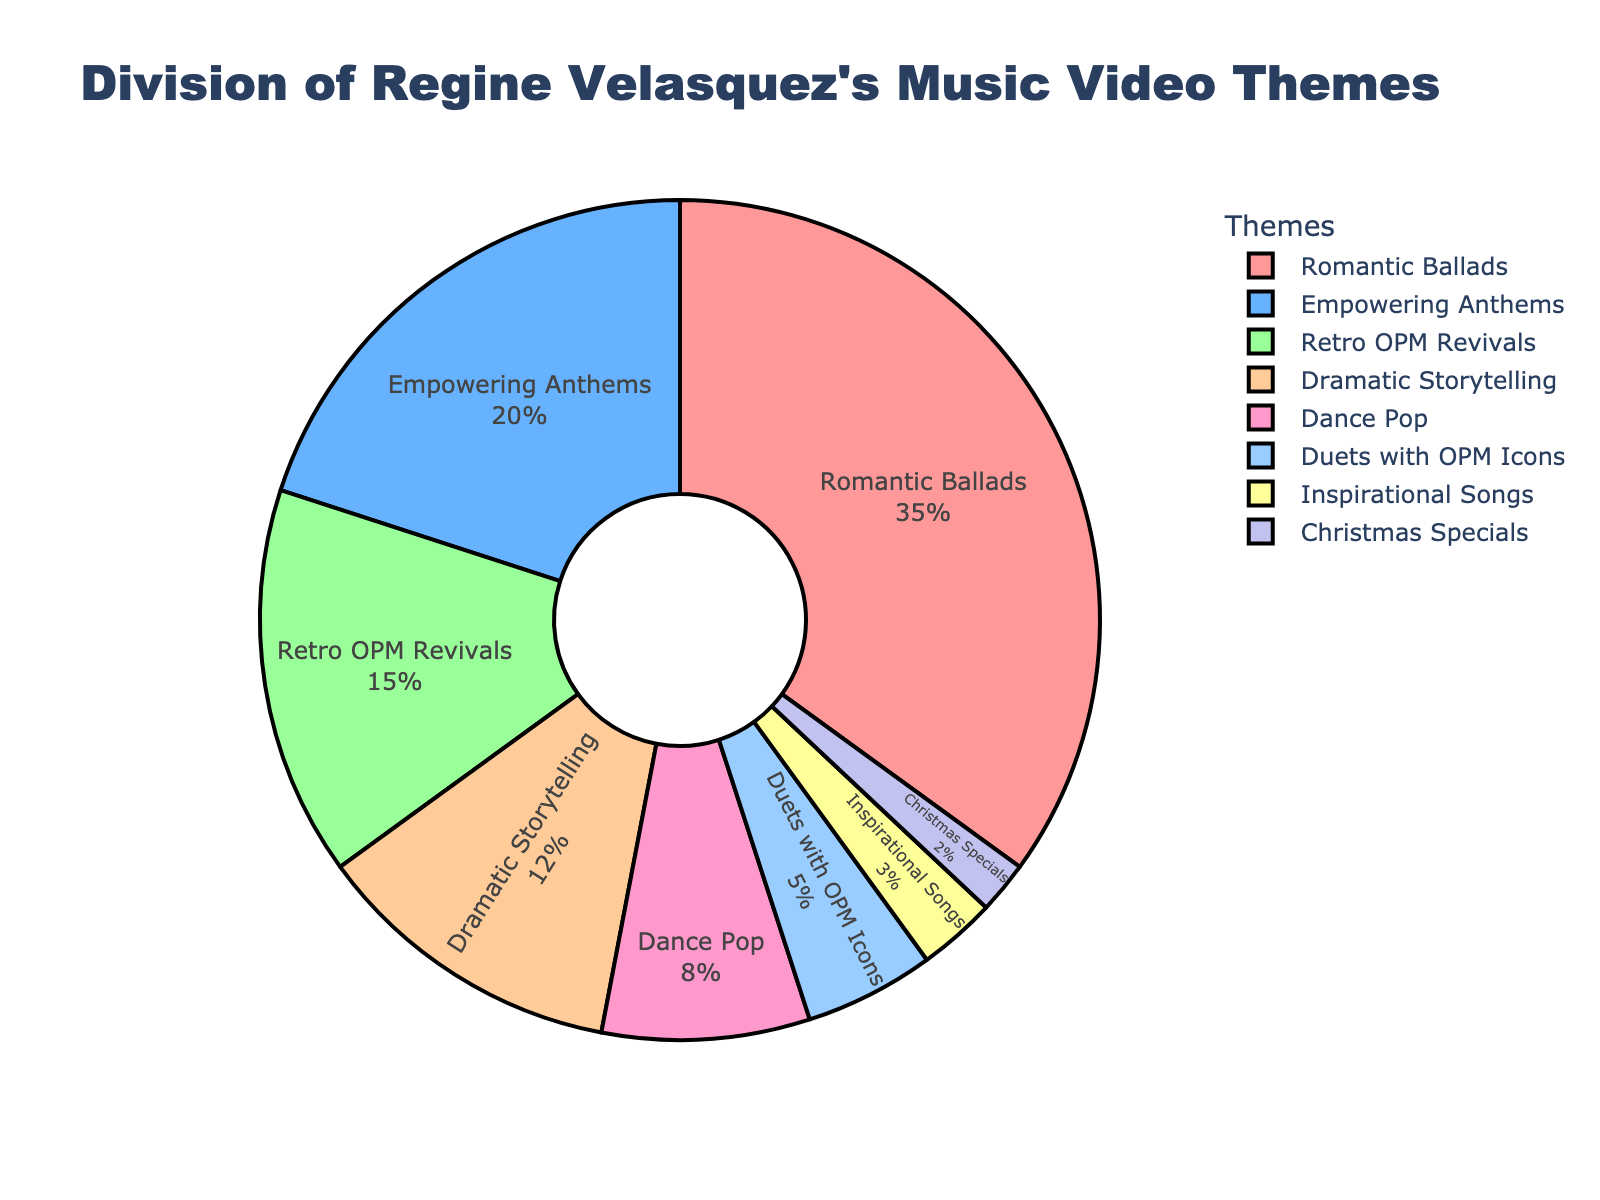What is the most common theme in Regine Velasquez's music videos? From the pie chart, the segment for Romantic Ballads occupies the largest area, making it the most common theme.
Answer: Romantic Ballads Which theme has the second highest percentage of music videos? By looking at the labeled segments and their percentages, Empowering Anthems is the second largest portion at 20%.
Answer: Empowering Anthems How much larger is the percentage of Romantic Ballads compared to Dance Pop? The percentage for Romantic Ballads is 35% and for Dance Pop is 8%. The difference between them is calculated as 35% - 8%.
Answer: 27% What's the combined percentage of the themes with a percentage less than 10%? Adding the percentages of Dance Pop (8%), Duets with OPM Icons (5%), Inspirational Songs (3%), and Christmas Specials (2%) gives us the sum of 8% + 5% + 3% + 2%.
Answer: 18% What's the percentage difference between Retro OPM Revivals and Dramatic Storytelling themes? Retro OPM Revivals is 15% and Dramatic Storytelling is 12%. Subtracting these values gives 15% - 12%.
Answer: 3% Which themes occupy less than 5% each in the pie chart? The themes that occupy less than 5% are Duets with OPM Icons (5%), Inspirational Songs (3%), and Christmas Specials (2%).
Answer: Inspirational Songs and Christmas Specials Are there more Romantic Ballads or more of the combined Empowering Anthems and Retro OPM Revivals? Romantic Ballads have 35%, while the combined percentage of Empowering Anthems (20%) and Retro OPM Revivals (15%) is 20% + 15%. Comparing 35% with 35% shows they are equal.
Answer: Equal Among the themes related to collaborations, which one has a higher percentage? The themes related to collaborations are Duets with OPM Icons at 5%. Since this is the only collaboration-related theme, it has the highest percentage by default.
Answer: Duets with OPM Icons What is the total percentage of all themes related to storytelling, including Romantic Ballads and Dramatic Storytelling? By combining the percentages of Romantic Ballads (35%) and Dramatic Storytelling (12%), the total is 35% + 12%.
Answer: 47% If you were to select two themes at random, is it more likely to get Romantic Ballads or a combination of Inspirational Songs and Christmas Specials? Romantic Ballads have a percentage of 35%, while the combination of Inspirational Songs (3%) and Christmas Specials (2%) results in 3% + 2%. Since 35% is greater than 5%, it is indeed more likely to get Romantic Ballads.
Answer: Romantic Ballads 